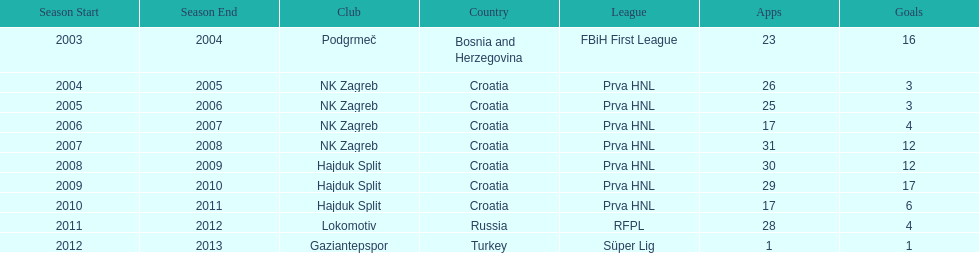After scoring against bulgaria in zenica, ibricic also scored against this team in a 7-0 victory in zenica less then a month after the friendly match against bulgaria. Estonia. 